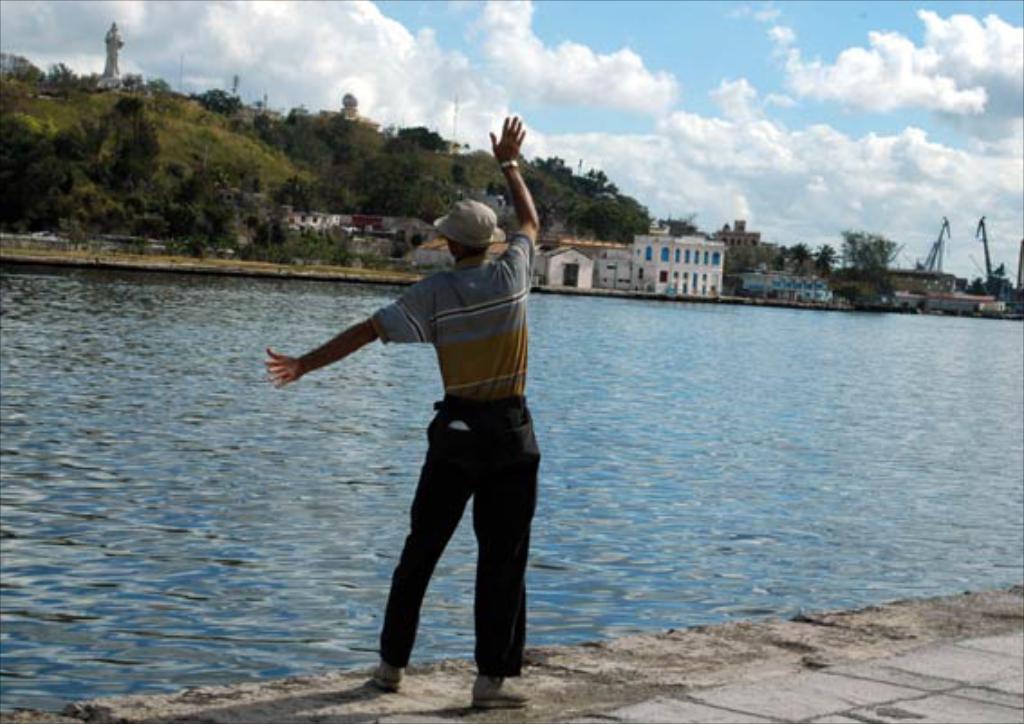How would you summarize this image in a sentence or two? In this picture I can see a person standing in front of the water lake, other side of the water there are some buildings and trees. 